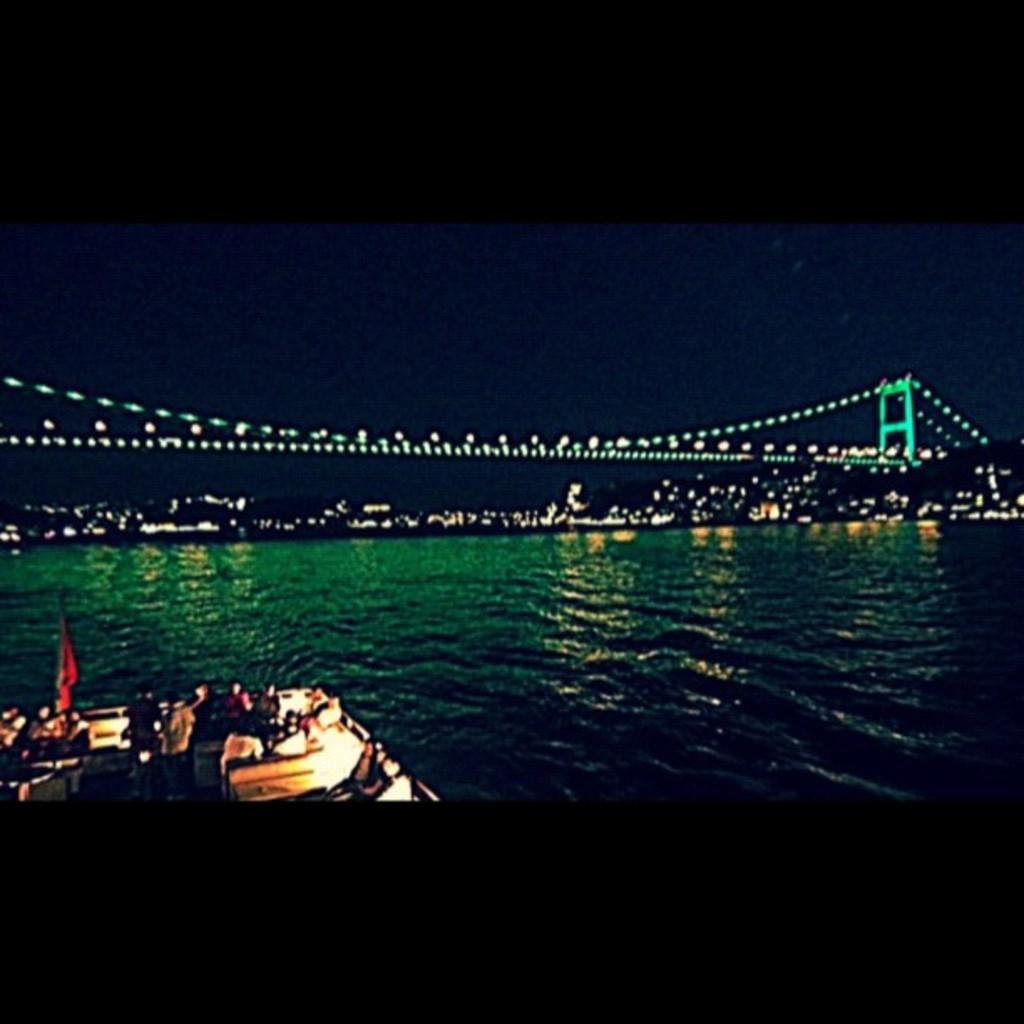What is the main subject of the image? The main subject of the image is a boat. Where is the boat located? The boat is on the water. Are there any people in the boat? Yes, there are people in the boat. What can be seen in the background of the image? There is a bridge and lights visible in the background of the image. What type of cloth is being used to unlock the door in the image? There is no cloth or door present in the image; it features a boat on the water with people in it and a background with a bridge and lights. 